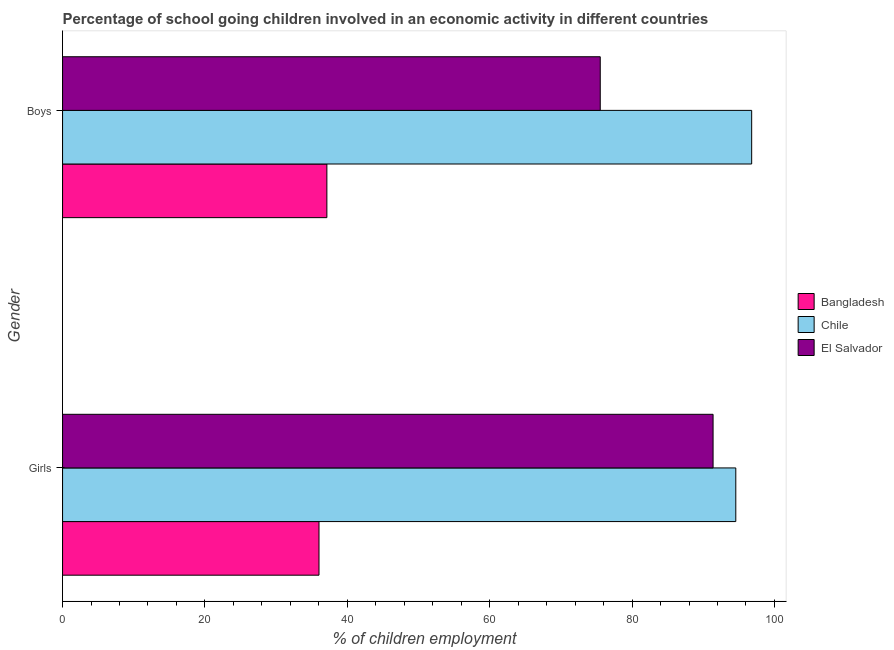Are the number of bars on each tick of the Y-axis equal?
Offer a very short reply. Yes. How many bars are there on the 1st tick from the bottom?
Offer a very short reply. 3. What is the label of the 1st group of bars from the top?
Offer a terse response. Boys. What is the percentage of school going boys in Bangladesh?
Provide a succinct answer. 37.13. Across all countries, what is the maximum percentage of school going girls?
Make the answer very short. 94.57. Across all countries, what is the minimum percentage of school going girls?
Provide a short and direct response. 36.02. In which country was the percentage of school going boys maximum?
Make the answer very short. Chile. In which country was the percentage of school going girls minimum?
Give a very brief answer. Bangladesh. What is the total percentage of school going boys in the graph?
Keep it short and to the point. 209.47. What is the difference between the percentage of school going girls in Bangladesh and that in Chile?
Give a very brief answer. -58.55. What is the difference between the percentage of school going boys in Bangladesh and the percentage of school going girls in Chile?
Ensure brevity in your answer.  -57.44. What is the average percentage of school going boys per country?
Make the answer very short. 69.82. What is the difference between the percentage of school going boys and percentage of school going girls in Chile?
Keep it short and to the point. 2.23. What is the ratio of the percentage of school going girls in Bangladesh to that in Chile?
Offer a very short reply. 0.38. Is the percentage of school going boys in Chile less than that in Bangladesh?
Provide a short and direct response. No. In how many countries, is the percentage of school going boys greater than the average percentage of school going boys taken over all countries?
Your answer should be compact. 2. What does the 1st bar from the top in Boys represents?
Provide a succinct answer. El Salvador. What does the 2nd bar from the bottom in Girls represents?
Offer a terse response. Chile. How many bars are there?
Your answer should be very brief. 6. Are all the bars in the graph horizontal?
Keep it short and to the point. Yes. How many countries are there in the graph?
Make the answer very short. 3. What is the difference between two consecutive major ticks on the X-axis?
Ensure brevity in your answer.  20. How many legend labels are there?
Make the answer very short. 3. What is the title of the graph?
Your answer should be very brief. Percentage of school going children involved in an economic activity in different countries. What is the label or title of the X-axis?
Your answer should be very brief. % of children employment. What is the % of children employment in Bangladesh in Girls?
Ensure brevity in your answer.  36.02. What is the % of children employment of Chile in Girls?
Your answer should be very brief. 94.57. What is the % of children employment in El Salvador in Girls?
Your answer should be very brief. 91.38. What is the % of children employment of Bangladesh in Boys?
Provide a succinct answer. 37.13. What is the % of children employment in Chile in Boys?
Ensure brevity in your answer.  96.81. What is the % of children employment of El Salvador in Boys?
Offer a terse response. 75.53. Across all Gender, what is the maximum % of children employment in Bangladesh?
Your response must be concise. 37.13. Across all Gender, what is the maximum % of children employment of Chile?
Give a very brief answer. 96.81. Across all Gender, what is the maximum % of children employment in El Salvador?
Give a very brief answer. 91.38. Across all Gender, what is the minimum % of children employment of Bangladesh?
Your answer should be very brief. 36.02. Across all Gender, what is the minimum % of children employment of Chile?
Ensure brevity in your answer.  94.57. Across all Gender, what is the minimum % of children employment in El Salvador?
Keep it short and to the point. 75.53. What is the total % of children employment of Bangladesh in the graph?
Your response must be concise. 73.15. What is the total % of children employment in Chile in the graph?
Make the answer very short. 191.38. What is the total % of children employment in El Salvador in the graph?
Provide a succinct answer. 166.92. What is the difference between the % of children employment in Bangladesh in Girls and that in Boys?
Provide a succinct answer. -1.11. What is the difference between the % of children employment in Chile in Girls and that in Boys?
Your response must be concise. -2.23. What is the difference between the % of children employment of El Salvador in Girls and that in Boys?
Offer a terse response. 15.85. What is the difference between the % of children employment in Bangladesh in Girls and the % of children employment in Chile in Boys?
Offer a very short reply. -60.78. What is the difference between the % of children employment in Bangladesh in Girls and the % of children employment in El Salvador in Boys?
Ensure brevity in your answer.  -39.51. What is the difference between the % of children employment in Chile in Girls and the % of children employment in El Salvador in Boys?
Ensure brevity in your answer.  19.04. What is the average % of children employment of Bangladesh per Gender?
Provide a short and direct response. 36.58. What is the average % of children employment of Chile per Gender?
Provide a succinct answer. 95.69. What is the average % of children employment in El Salvador per Gender?
Offer a terse response. 83.46. What is the difference between the % of children employment of Bangladesh and % of children employment of Chile in Girls?
Provide a succinct answer. -58.55. What is the difference between the % of children employment of Bangladesh and % of children employment of El Salvador in Girls?
Provide a succinct answer. -55.36. What is the difference between the % of children employment of Chile and % of children employment of El Salvador in Girls?
Offer a very short reply. 3.19. What is the difference between the % of children employment in Bangladesh and % of children employment in Chile in Boys?
Your response must be concise. -59.68. What is the difference between the % of children employment of Bangladesh and % of children employment of El Salvador in Boys?
Your response must be concise. -38.4. What is the difference between the % of children employment in Chile and % of children employment in El Salvador in Boys?
Provide a short and direct response. 21.27. What is the ratio of the % of children employment in Bangladesh in Girls to that in Boys?
Your response must be concise. 0.97. What is the ratio of the % of children employment in Chile in Girls to that in Boys?
Provide a short and direct response. 0.98. What is the ratio of the % of children employment in El Salvador in Girls to that in Boys?
Offer a terse response. 1.21. What is the difference between the highest and the second highest % of children employment of Bangladesh?
Keep it short and to the point. 1.11. What is the difference between the highest and the second highest % of children employment in Chile?
Ensure brevity in your answer.  2.23. What is the difference between the highest and the second highest % of children employment in El Salvador?
Give a very brief answer. 15.85. What is the difference between the highest and the lowest % of children employment in Bangladesh?
Provide a short and direct response. 1.11. What is the difference between the highest and the lowest % of children employment in Chile?
Offer a terse response. 2.23. What is the difference between the highest and the lowest % of children employment of El Salvador?
Provide a short and direct response. 15.85. 